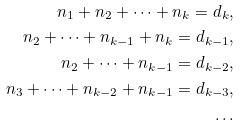Convert formula to latex. <formula><loc_0><loc_0><loc_500><loc_500>n _ { 1 } + n _ { 2 } + \dots + n _ { k } = d _ { k } , \\ n _ { 2 } + \dots + n _ { k - 1 } + n _ { k } = d _ { k - 1 } , \\ n _ { 2 } + \dots + n _ { k - 1 } = d _ { k - 2 } , \\ n _ { 3 } + \dots + n _ { k - 2 } + n _ { k - 1 } = d _ { k - 3 } , \\ \dots</formula> 